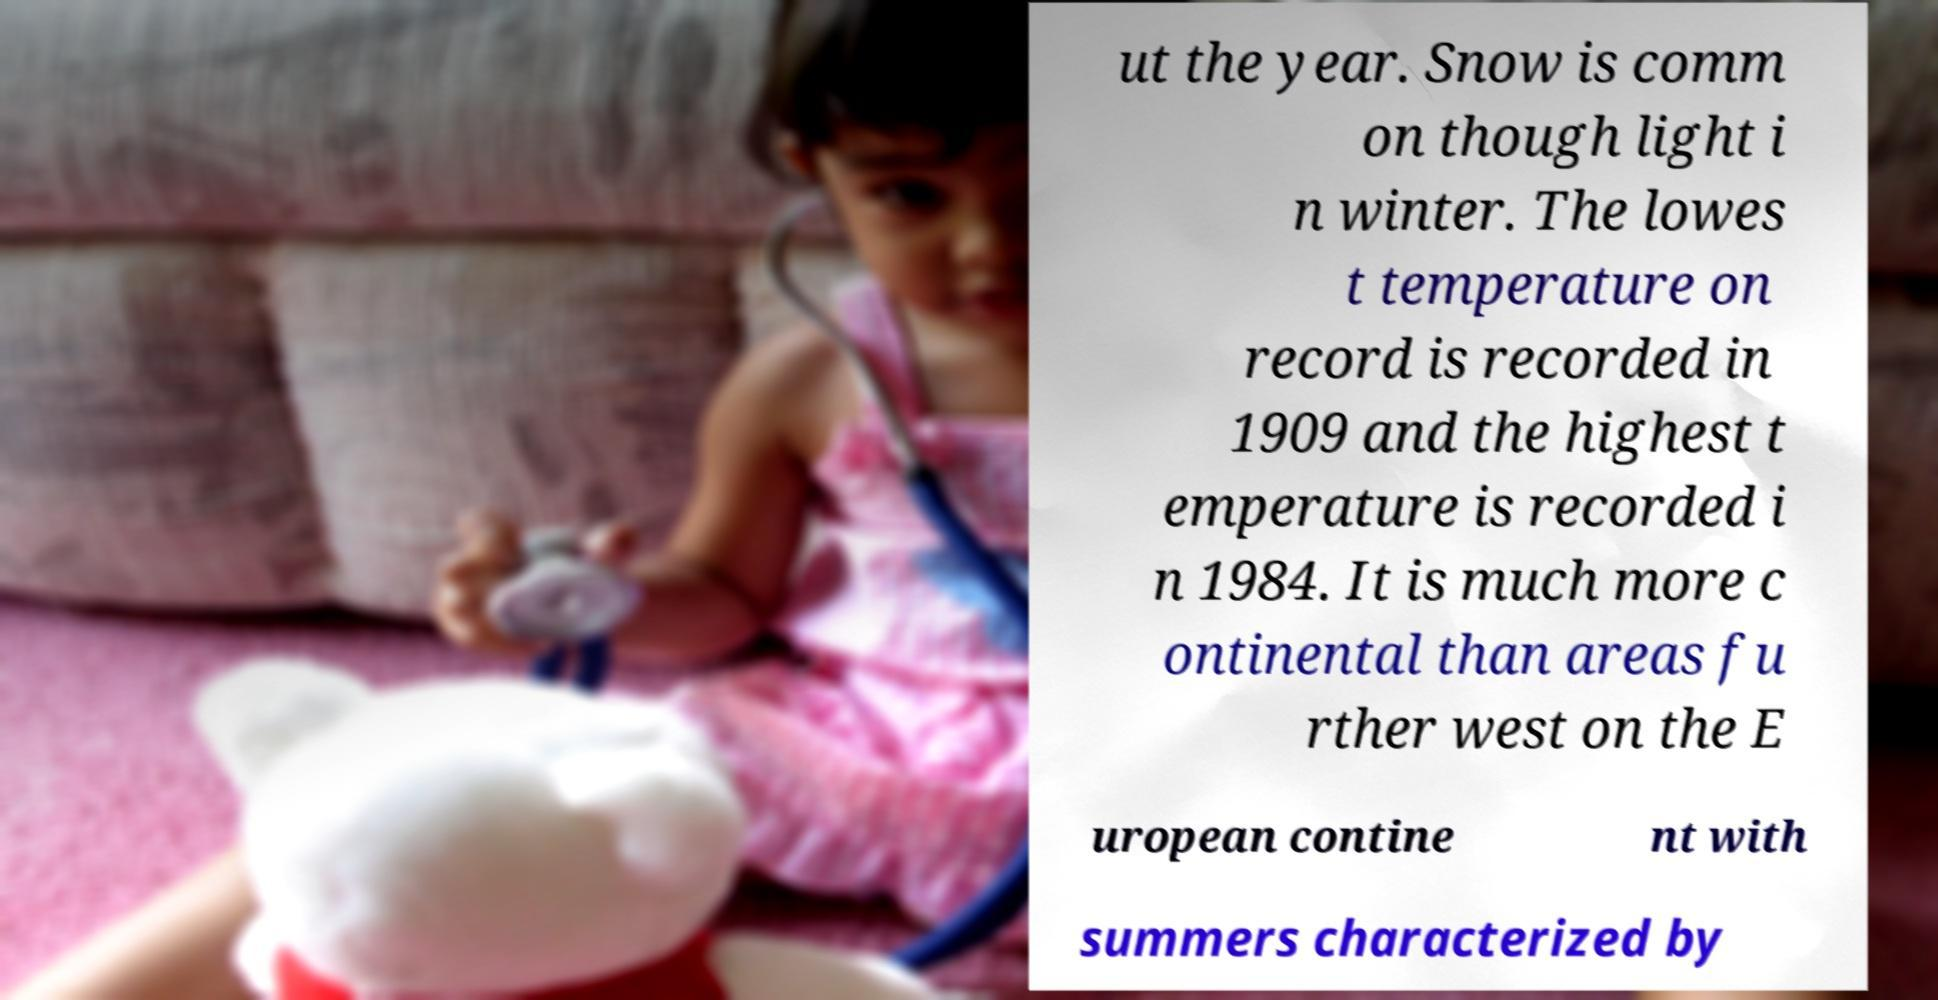There's text embedded in this image that I need extracted. Can you transcribe it verbatim? ut the year. Snow is comm on though light i n winter. The lowes t temperature on record is recorded in 1909 and the highest t emperature is recorded i n 1984. It is much more c ontinental than areas fu rther west on the E uropean contine nt with summers characterized by 